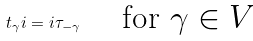<formula> <loc_0><loc_0><loc_500><loc_500>t _ { \gamma } i = i \tau _ { - \gamma } \quad \text { for $\gamma\in V$}</formula> 